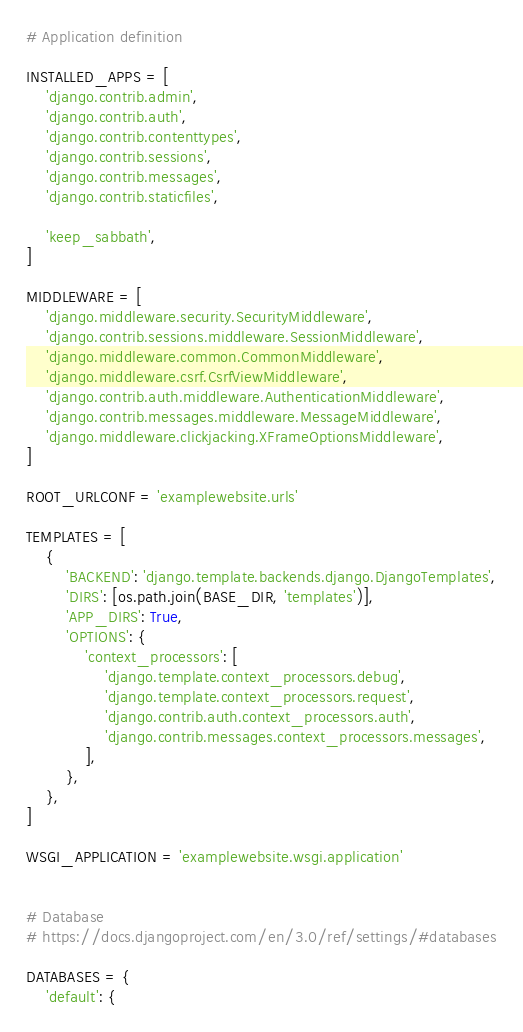Convert code to text. <code><loc_0><loc_0><loc_500><loc_500><_Python_>

# Application definition

INSTALLED_APPS = [
    'django.contrib.admin',
    'django.contrib.auth',
    'django.contrib.contenttypes',
    'django.contrib.sessions',
    'django.contrib.messages',
    'django.contrib.staticfiles',

    'keep_sabbath',
]

MIDDLEWARE = [
    'django.middleware.security.SecurityMiddleware',
    'django.contrib.sessions.middleware.SessionMiddleware',
    'django.middleware.common.CommonMiddleware',
    'django.middleware.csrf.CsrfViewMiddleware',
    'django.contrib.auth.middleware.AuthenticationMiddleware',
    'django.contrib.messages.middleware.MessageMiddleware',
    'django.middleware.clickjacking.XFrameOptionsMiddleware',
]

ROOT_URLCONF = 'examplewebsite.urls'

TEMPLATES = [
    {
        'BACKEND': 'django.template.backends.django.DjangoTemplates',
        'DIRS': [os.path.join(BASE_DIR, 'templates')],
        'APP_DIRS': True,
        'OPTIONS': {
            'context_processors': [
                'django.template.context_processors.debug',
                'django.template.context_processors.request',
                'django.contrib.auth.context_processors.auth',
                'django.contrib.messages.context_processors.messages',
            ],
        },
    },
]

WSGI_APPLICATION = 'examplewebsite.wsgi.application'


# Database
# https://docs.djangoproject.com/en/3.0/ref/settings/#databases

DATABASES = {
    'default': {</code> 